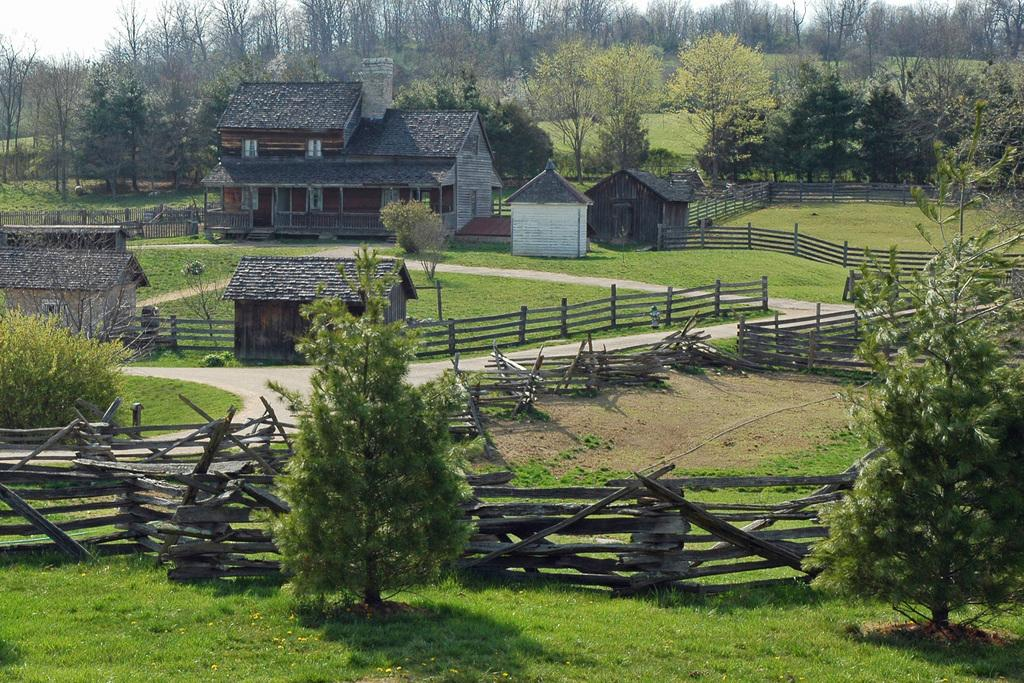What type of fence is visible in the image? There is a wooden fence in the image. What structures can be seen in the image? There are houses in the image. What type of vegetation is present in the image? There are trees in the image. What type of illumination is present in the image? There are lights in the image. What type of ground surface is visible at the bottom of the image? There is grass at the bottom of the image. What part of the natural environment is visible at the top of the image? There is sky at the top of the image. Where is the fireman located in the image? There is no fireman present in the image. What type of yoke is being used by the animals in the image? There are no animals or yokes present in the image. 